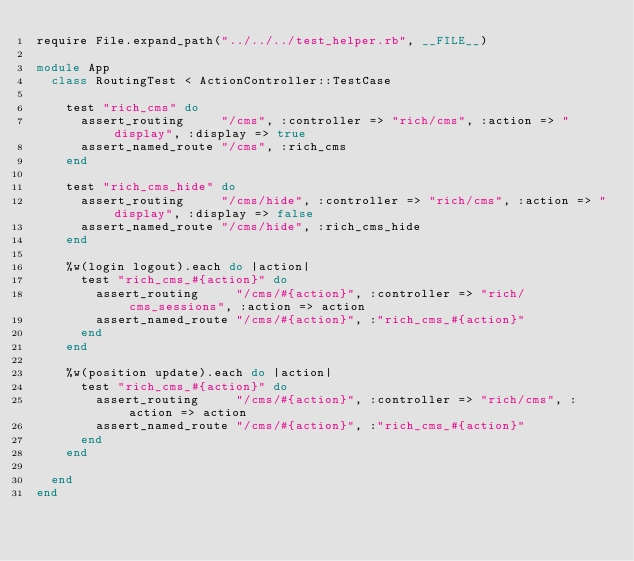Convert code to text. <code><loc_0><loc_0><loc_500><loc_500><_Ruby_>require File.expand_path("../../../test_helper.rb", __FILE__)

module App
  class RoutingTest < ActionController::TestCase

    test "rich_cms" do
      assert_routing     "/cms", :controller => "rich/cms", :action => "display", :display => true
      assert_named_route "/cms", :rich_cms
    end

    test "rich_cms_hide" do
      assert_routing     "/cms/hide", :controller => "rich/cms", :action => "display", :display => false
      assert_named_route "/cms/hide", :rich_cms_hide
    end

    %w(login logout).each do |action|
      test "rich_cms_#{action}" do
        assert_routing     "/cms/#{action}", :controller => "rich/cms_sessions", :action => action
        assert_named_route "/cms/#{action}", :"rich_cms_#{action}"
      end
    end

    %w(position update).each do |action|
      test "rich_cms_#{action}" do
        assert_routing     "/cms/#{action}", :controller => "rich/cms", :action => action
        assert_named_route "/cms/#{action}", :"rich_cms_#{action}"
      end
    end

  end
end</code> 